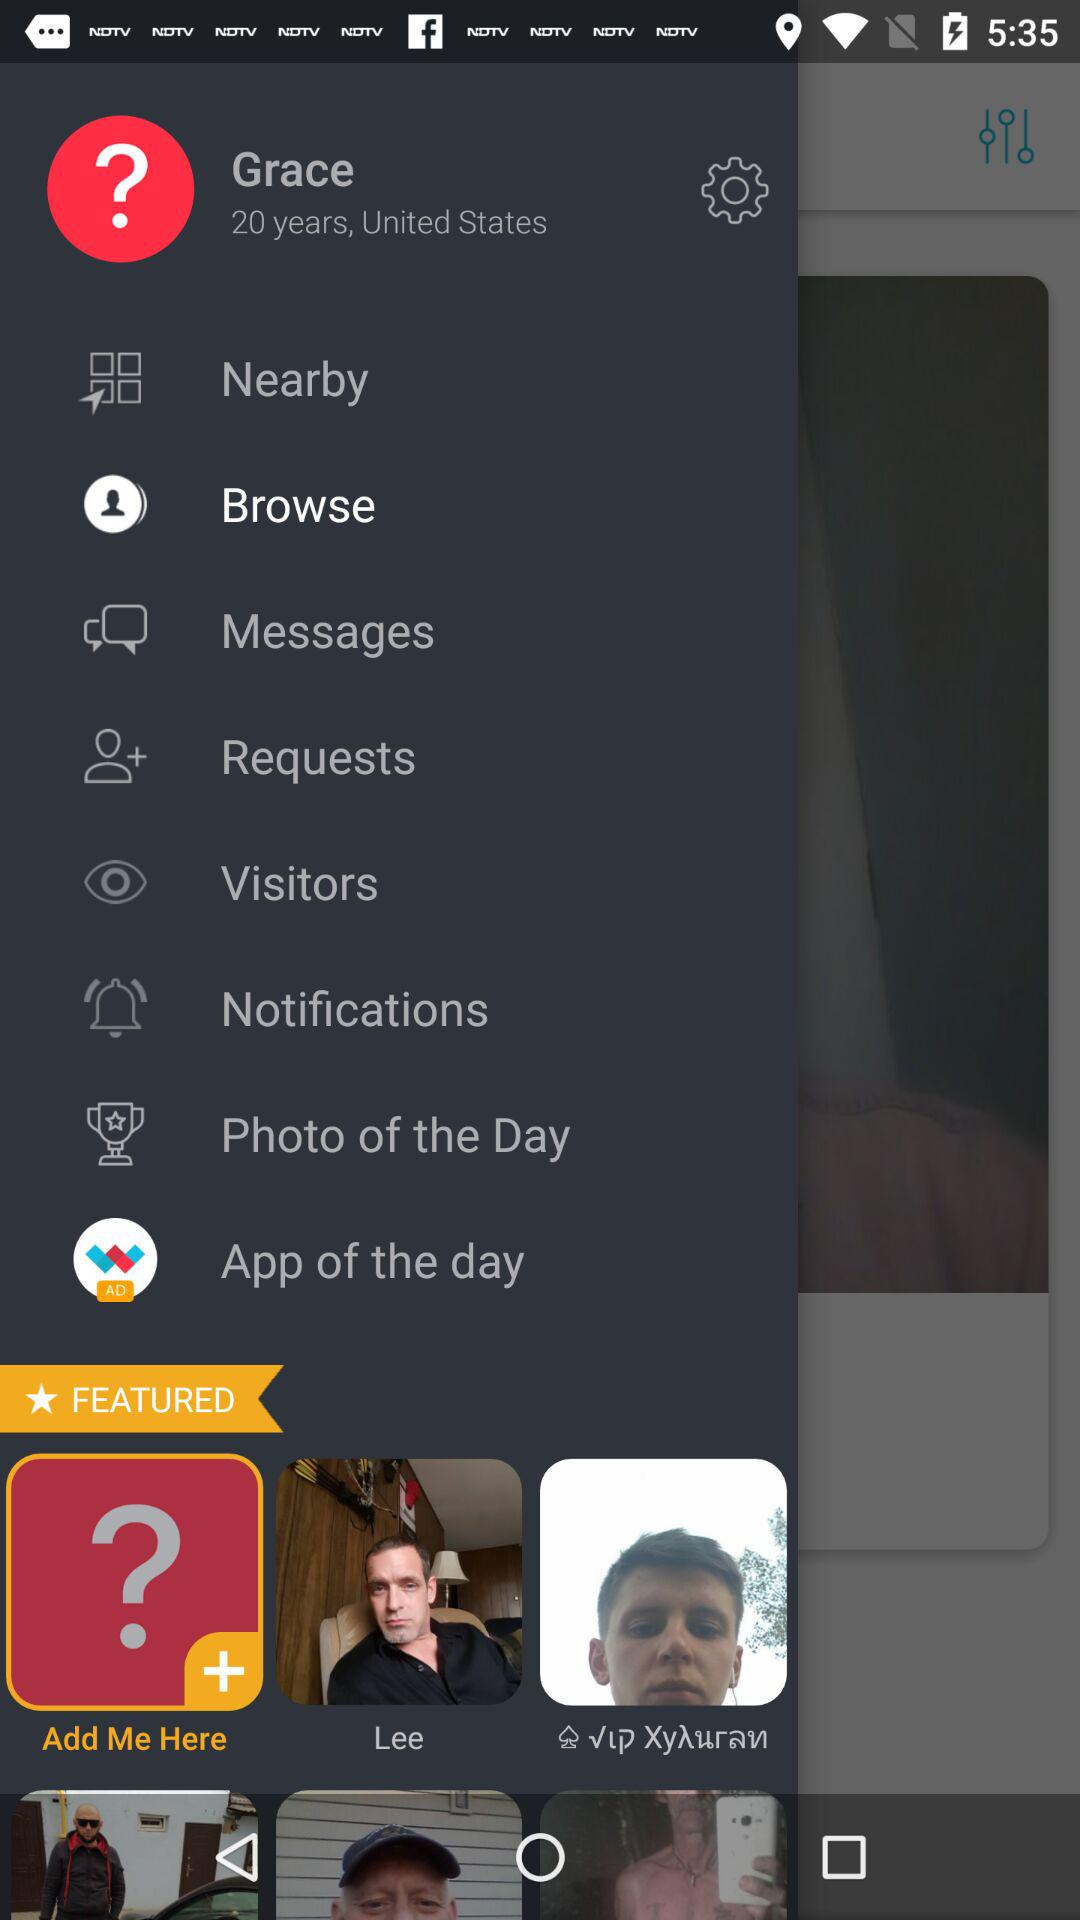What is the user name? The user name is Grace. 